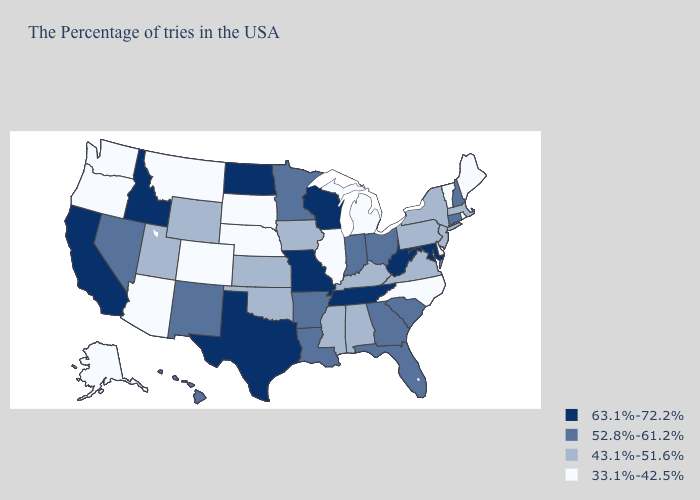Which states hav the highest value in the MidWest?
Quick response, please. Wisconsin, Missouri, North Dakota. What is the lowest value in the South?
Answer briefly. 33.1%-42.5%. What is the value of New York?
Quick response, please. 43.1%-51.6%. Does Iowa have the lowest value in the USA?
Quick response, please. No. Among the states that border Connecticut , which have the lowest value?
Answer briefly. Rhode Island. Which states have the highest value in the USA?
Keep it brief. Maryland, West Virginia, Tennessee, Wisconsin, Missouri, Texas, North Dakota, Idaho, California. What is the value of Oregon?
Quick response, please. 33.1%-42.5%. What is the lowest value in states that border South Dakota?
Be succinct. 33.1%-42.5%. Name the states that have a value in the range 33.1%-42.5%?
Keep it brief. Maine, Rhode Island, Vermont, Delaware, North Carolina, Michigan, Illinois, Nebraska, South Dakota, Colorado, Montana, Arizona, Washington, Oregon, Alaska. Which states have the highest value in the USA?
Write a very short answer. Maryland, West Virginia, Tennessee, Wisconsin, Missouri, Texas, North Dakota, Idaho, California. What is the value of Ohio?
Concise answer only. 52.8%-61.2%. What is the value of Texas?
Concise answer only. 63.1%-72.2%. Which states have the lowest value in the USA?
Write a very short answer. Maine, Rhode Island, Vermont, Delaware, North Carolina, Michigan, Illinois, Nebraska, South Dakota, Colorado, Montana, Arizona, Washington, Oregon, Alaska. Which states have the lowest value in the USA?
Answer briefly. Maine, Rhode Island, Vermont, Delaware, North Carolina, Michigan, Illinois, Nebraska, South Dakota, Colorado, Montana, Arizona, Washington, Oregon, Alaska. Among the states that border Indiana , does Michigan have the lowest value?
Give a very brief answer. Yes. 